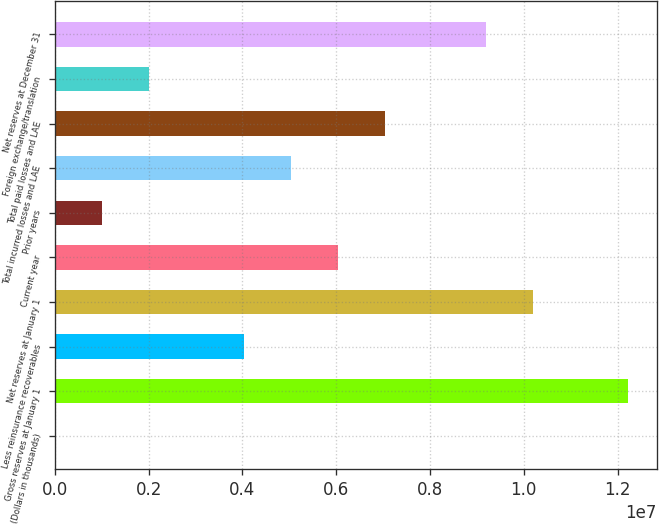Convert chart. <chart><loc_0><loc_0><loc_500><loc_500><bar_chart><fcel>(Dollars in thousands)<fcel>Gross reserves at January 1<fcel>Less reinsurance recoverables<fcel>Net reserves at January 1<fcel>Current year<fcel>Prior years<fcel>Total incurred losses and LAE<fcel>Total paid losses and LAE<fcel>Foreign exchange/translation<fcel>Net reserves at December 31<nl><fcel>2013<fcel>1.22195e+07<fcel>4.02883e+06<fcel>1.02061e+07<fcel>6.04224e+06<fcel>1.00872e+06<fcel>5.03553e+06<fcel>7.04894e+06<fcel>2.01542e+06<fcel>9.19937e+06<nl></chart> 